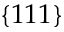Convert formula to latex. <formula><loc_0><loc_0><loc_500><loc_500>\{ 1 1 1 \}</formula> 